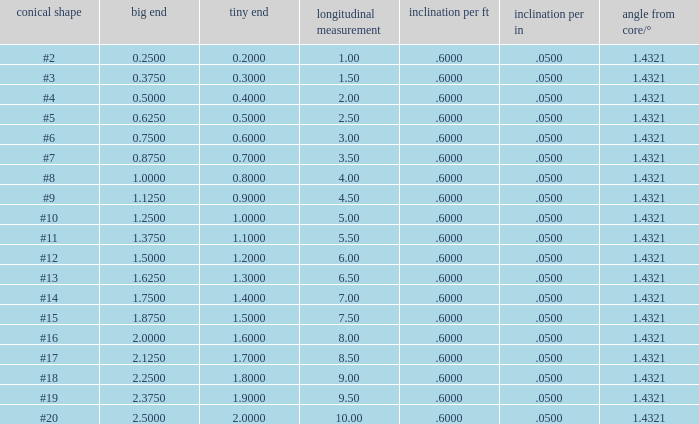Which Large end has a Taper/ft smaller than 0.6000000000000001? 19.0. 